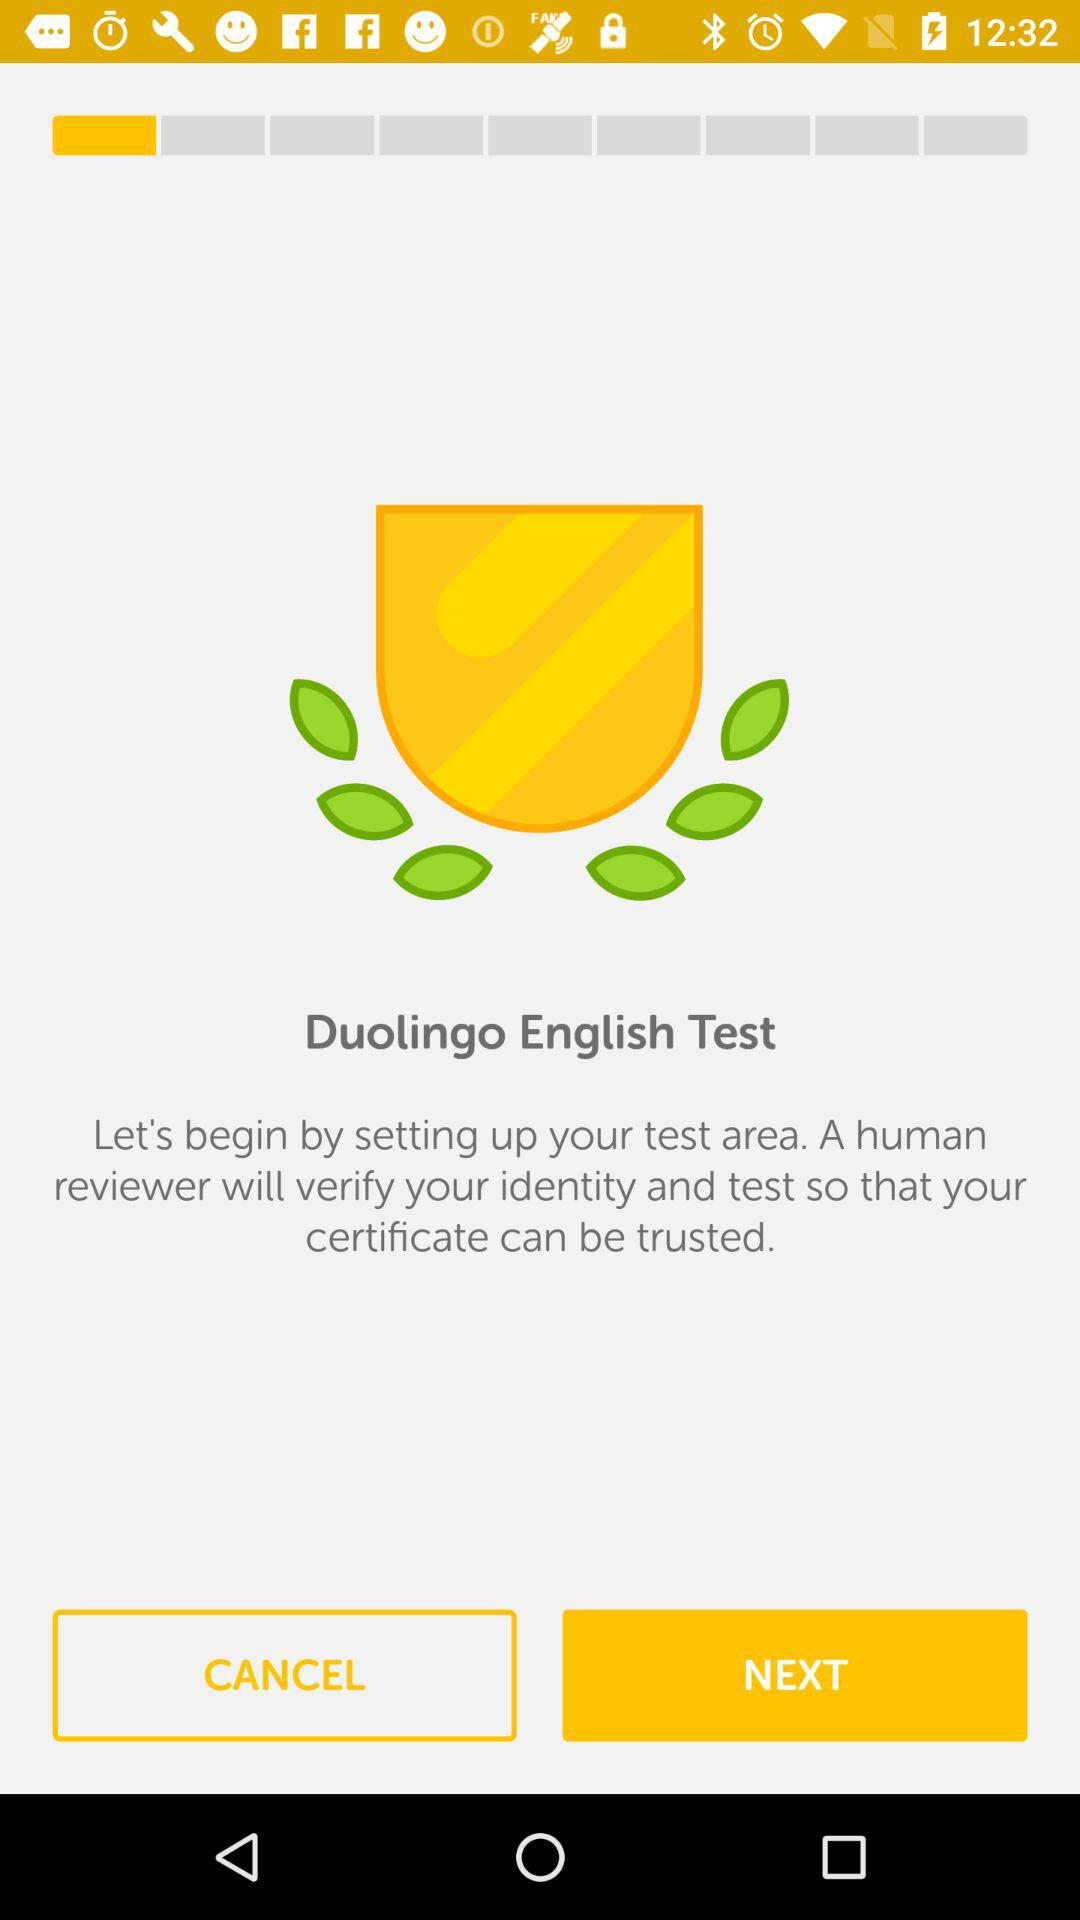What is the application name? The application name is "Duolingo". 